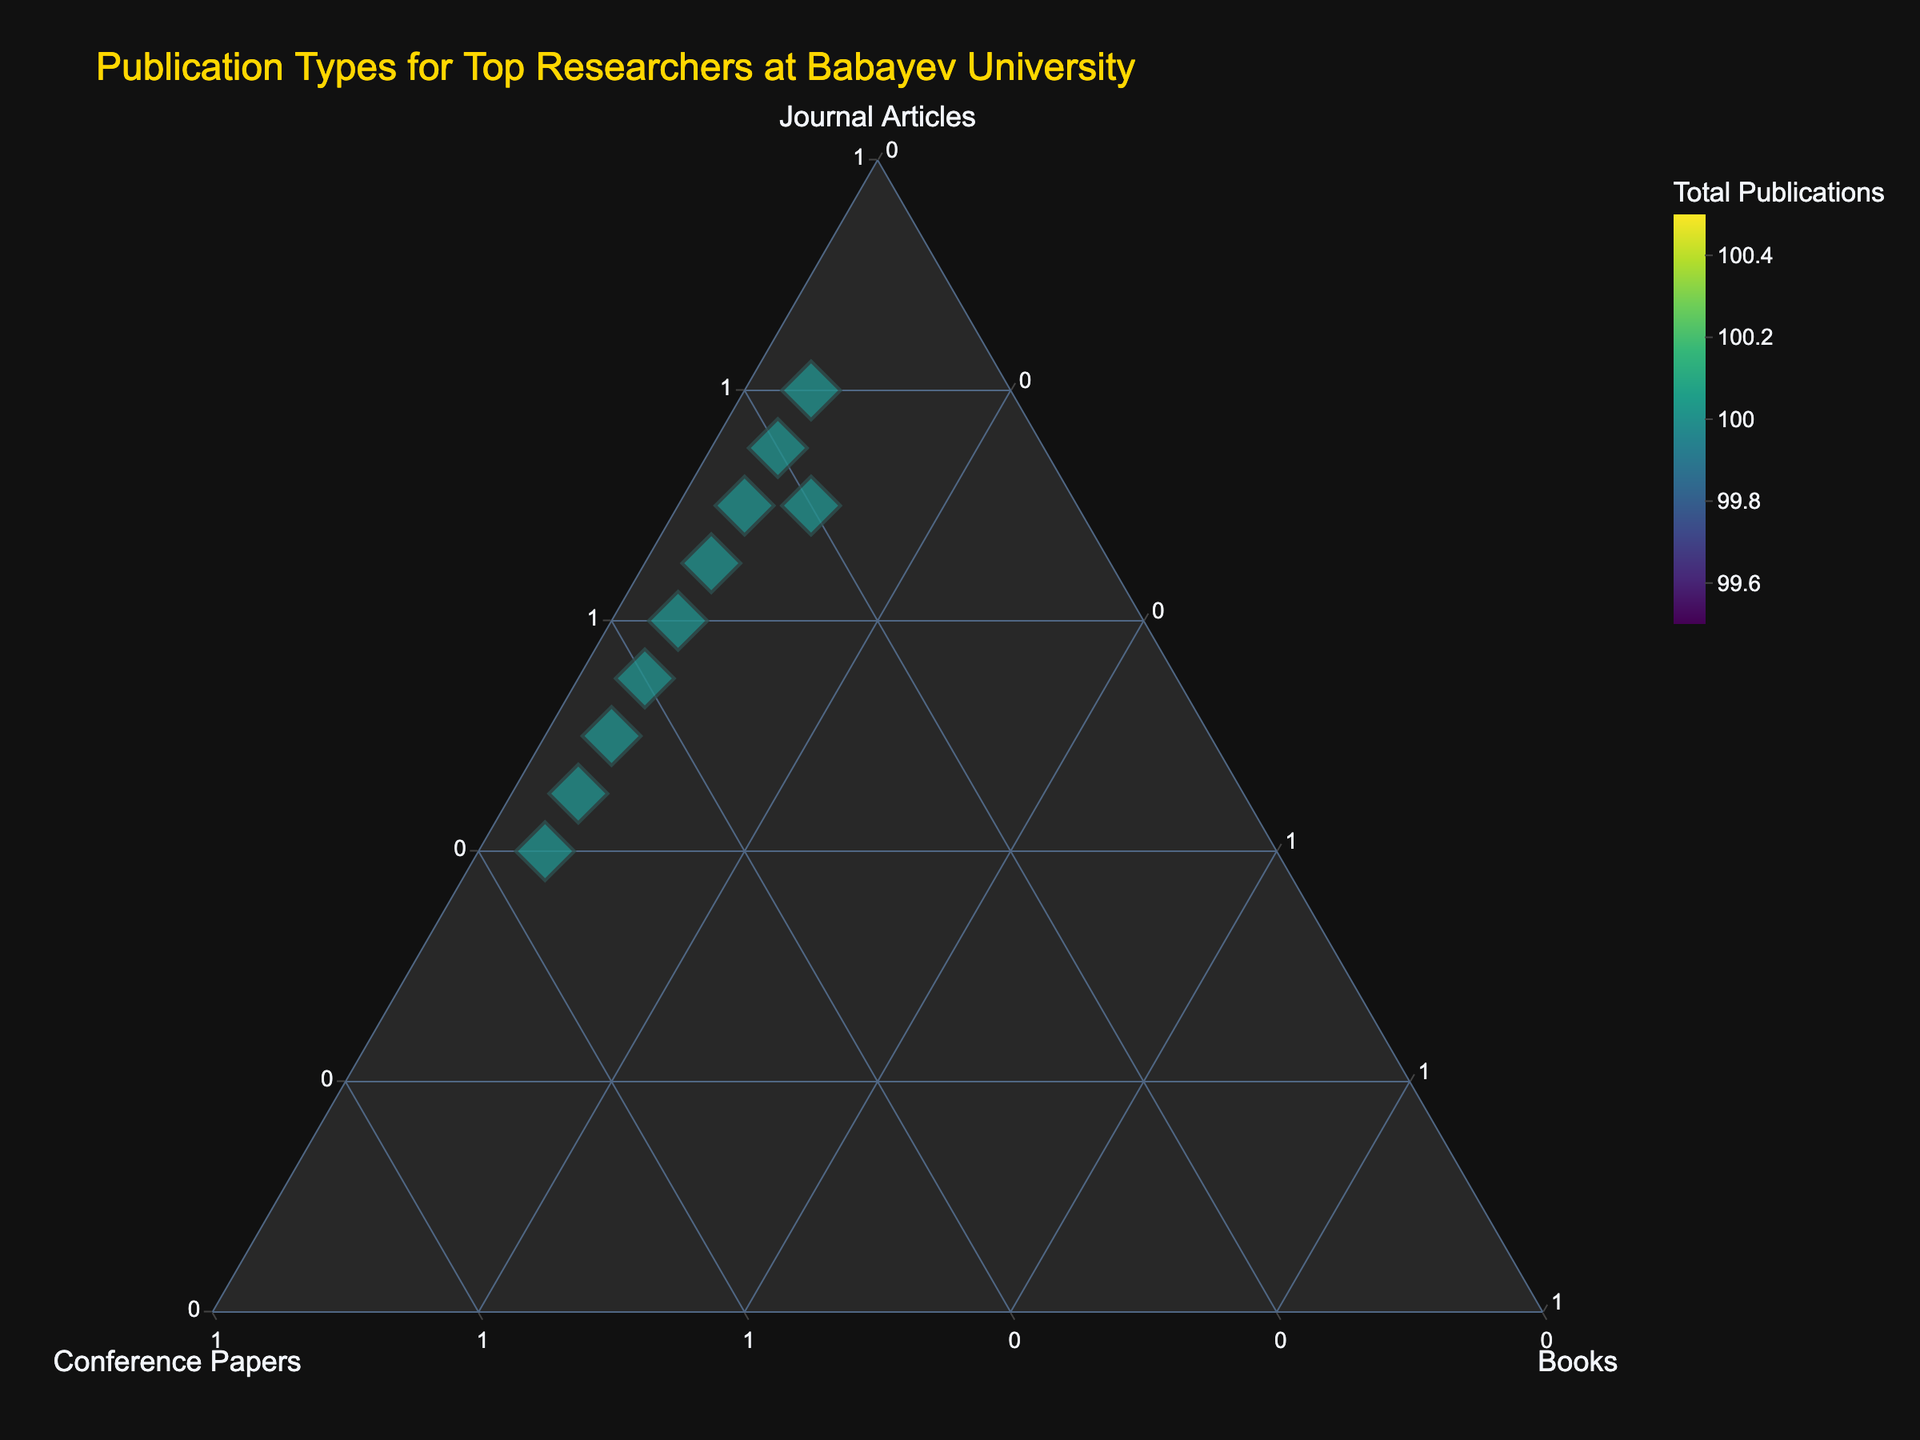How many researchers are represented in the figure? Count the number of distinct data points (diamonds) in the plot. Each point represents a researcher from the provided data.
Answer: 10 Which researcher has the highest proportion of conference papers? Observe the positions of the data points in the plot. The researcher with the highest proportion of conference papers will be closest to the "Conference Papers" vertex.
Answer: Dr. Suleymanov Are there any researchers with an equal proportion of journal articles and conference papers? Look for points that lie on a line equidistant from the journal articles and conference papers vertices but away from the books vertex.
Answer: No Which researcher has the most balanced publication distribution across all three types? Identify the researcher whose data point is closest to the center of the plot, indicating a more even distribution between the three publication types.
Answer: Prof. Huseynova Who has the highest total number of publications, and how is this visualized? Look for the largest data point (diamond) in terms of size. The size represents the total number of publications.
Answer: Prof. Karimova What is the proportion of journal articles for Dr. Rustamov? Find Dr. Rustamov on the plot and read off the 'Journal Articles %' value by observing the proportion on the 'Journal Articles' axis.
Answer: 45% Compare the publication types of Prof. Ismayilova and Dr. Hasanov. Who has a higher proportion of journal articles? Locate the data points for both researchers and compare their positions relative to the 'Journal Articles' vertex.
Answer: Prof. Ismayilova How does Dr. Aliyev's publication profile compare to Dr. Nabiyev’s in terms of conference papers? Locate both researchers' data points and compare their positions relative to the 'Conference Papers' vertex. Dr. Nabiyev's point should be closer if he has a higher proportion.
Answer: Dr. Nabiyev has more conference papers What trend can you observe about the researchers with 5% books? Identify the researchers with a consistent 5% books proportion and observe their distribution of journal articles and conference papers. They are more spread out towards the journal articles and conference papers vertices rather than clustering near the books vertex.
Answer: They have diverse distributions of journal articles and conference papers Would Dr. Suleymanov's point be closer or farther from the books vertex if the proportion of books increased to 10%? If the proportion of books increased, the point would shift closer to the 'Books' vertex since the plot dynamically adjusts to reflect new proportions.
Answer: Closer 